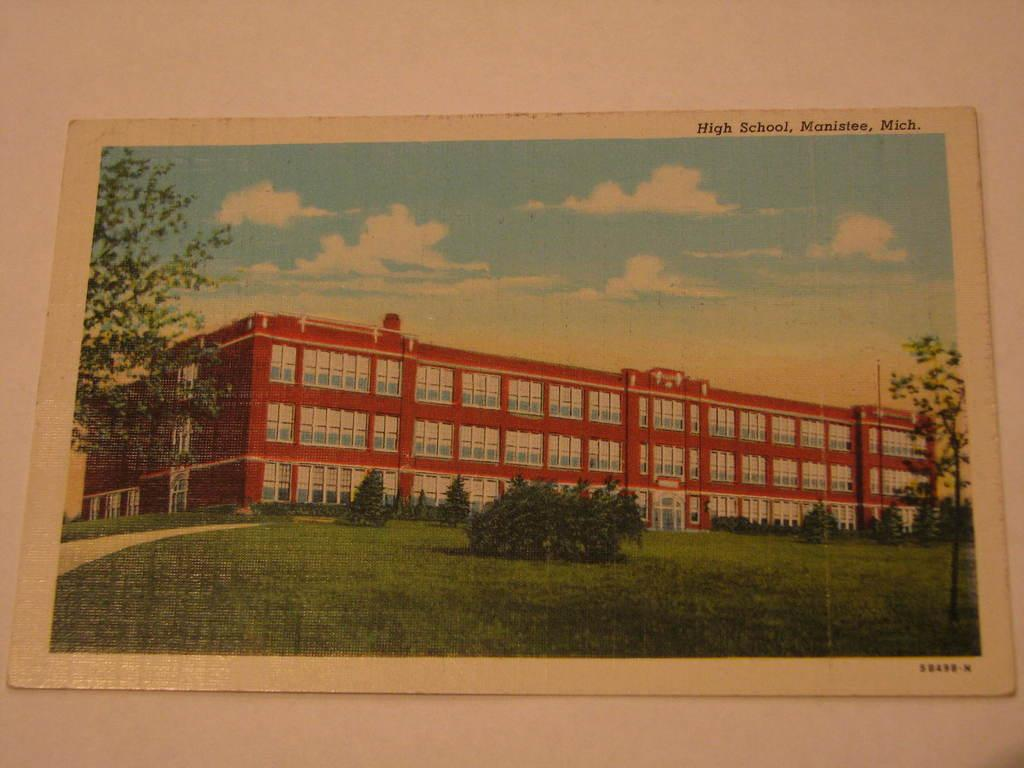What type of frame is in the image? There is a paper frame in the image. What is depicted inside the paper frame? The paper frame contains a picture of a building. What type of natural environment is visible in the image? There are trees, grass, and a path visible in the image. What is visible in the sky in the image? The sky is visible in the image, and there are clouds present. Where is the paper frame located in the image? The paper frame is attached to a plain wall. Is there any text on the paper frame? Yes, there is text on the paper frame. Can you see a bat flying near the trees in the image? There is no bat visible in the image; only trees, grass, and a path are present in the natural environment. 